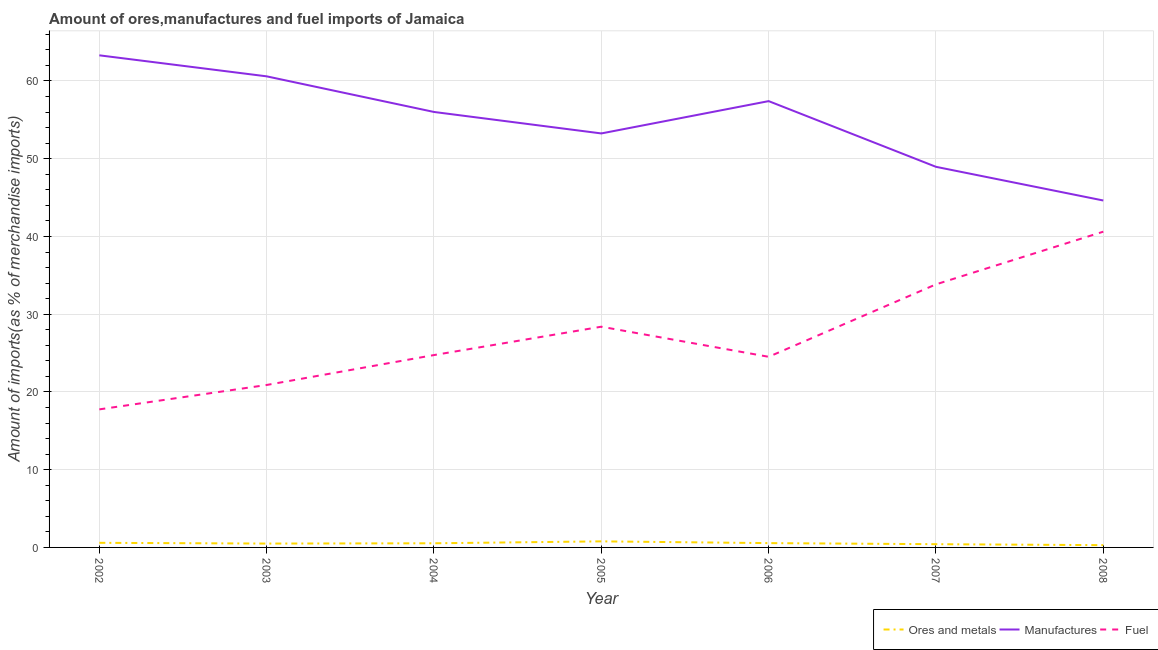Is the number of lines equal to the number of legend labels?
Your answer should be very brief. Yes. What is the percentage of fuel imports in 2008?
Keep it short and to the point. 40.62. Across all years, what is the maximum percentage of manufactures imports?
Keep it short and to the point. 63.3. Across all years, what is the minimum percentage of ores and metals imports?
Your response must be concise. 0.29. In which year was the percentage of manufactures imports minimum?
Keep it short and to the point. 2008. What is the total percentage of ores and metals imports in the graph?
Offer a very short reply. 3.67. What is the difference between the percentage of manufactures imports in 2004 and that in 2005?
Make the answer very short. 2.76. What is the difference between the percentage of ores and metals imports in 2004 and the percentage of fuel imports in 2005?
Offer a terse response. -27.86. What is the average percentage of manufactures imports per year?
Your answer should be very brief. 54.88. In the year 2007, what is the difference between the percentage of manufactures imports and percentage of ores and metals imports?
Your answer should be compact. 48.54. What is the ratio of the percentage of ores and metals imports in 2007 to that in 2008?
Your response must be concise. 1.43. Is the percentage of manufactures imports in 2007 less than that in 2008?
Ensure brevity in your answer.  No. What is the difference between the highest and the second highest percentage of manufactures imports?
Make the answer very short. 2.7. What is the difference between the highest and the lowest percentage of manufactures imports?
Your answer should be very brief. 18.68. Is the percentage of manufactures imports strictly greater than the percentage of fuel imports over the years?
Your answer should be compact. Yes. Is the percentage of manufactures imports strictly less than the percentage of fuel imports over the years?
Offer a very short reply. No. How many years are there in the graph?
Ensure brevity in your answer.  7. What is the difference between two consecutive major ticks on the Y-axis?
Give a very brief answer. 10. Does the graph contain grids?
Offer a terse response. Yes. What is the title of the graph?
Your response must be concise. Amount of ores,manufactures and fuel imports of Jamaica. What is the label or title of the Y-axis?
Offer a terse response. Amount of imports(as % of merchandise imports). What is the Amount of imports(as % of merchandise imports) of Ores and metals in 2002?
Provide a succinct answer. 0.59. What is the Amount of imports(as % of merchandise imports) in Manufactures in 2002?
Offer a very short reply. 63.3. What is the Amount of imports(as % of merchandise imports) in Fuel in 2002?
Keep it short and to the point. 17.76. What is the Amount of imports(as % of merchandise imports) in Ores and metals in 2003?
Provide a succinct answer. 0.5. What is the Amount of imports(as % of merchandise imports) in Manufactures in 2003?
Make the answer very short. 60.6. What is the Amount of imports(as % of merchandise imports) in Fuel in 2003?
Your answer should be very brief. 20.9. What is the Amount of imports(as % of merchandise imports) of Ores and metals in 2004?
Make the answer very short. 0.53. What is the Amount of imports(as % of merchandise imports) in Manufactures in 2004?
Make the answer very short. 56.01. What is the Amount of imports(as % of merchandise imports) of Fuel in 2004?
Offer a very short reply. 24.74. What is the Amount of imports(as % of merchandise imports) of Ores and metals in 2005?
Give a very brief answer. 0.78. What is the Amount of imports(as % of merchandise imports) of Manufactures in 2005?
Your answer should be very brief. 53.25. What is the Amount of imports(as % of merchandise imports) of Fuel in 2005?
Offer a terse response. 28.39. What is the Amount of imports(as % of merchandise imports) of Ores and metals in 2006?
Provide a short and direct response. 0.55. What is the Amount of imports(as % of merchandise imports) in Manufactures in 2006?
Provide a succinct answer. 57.41. What is the Amount of imports(as % of merchandise imports) in Fuel in 2006?
Keep it short and to the point. 24.52. What is the Amount of imports(as % of merchandise imports) of Ores and metals in 2007?
Your response must be concise. 0.42. What is the Amount of imports(as % of merchandise imports) in Manufactures in 2007?
Provide a succinct answer. 48.96. What is the Amount of imports(as % of merchandise imports) in Fuel in 2007?
Provide a short and direct response. 33.84. What is the Amount of imports(as % of merchandise imports) of Ores and metals in 2008?
Your response must be concise. 0.29. What is the Amount of imports(as % of merchandise imports) in Manufactures in 2008?
Keep it short and to the point. 44.63. What is the Amount of imports(as % of merchandise imports) in Fuel in 2008?
Provide a succinct answer. 40.62. Across all years, what is the maximum Amount of imports(as % of merchandise imports) of Ores and metals?
Keep it short and to the point. 0.78. Across all years, what is the maximum Amount of imports(as % of merchandise imports) of Manufactures?
Provide a succinct answer. 63.3. Across all years, what is the maximum Amount of imports(as % of merchandise imports) in Fuel?
Your response must be concise. 40.62. Across all years, what is the minimum Amount of imports(as % of merchandise imports) of Ores and metals?
Give a very brief answer. 0.29. Across all years, what is the minimum Amount of imports(as % of merchandise imports) of Manufactures?
Provide a succinct answer. 44.63. Across all years, what is the minimum Amount of imports(as % of merchandise imports) of Fuel?
Give a very brief answer. 17.76. What is the total Amount of imports(as % of merchandise imports) in Ores and metals in the graph?
Make the answer very short. 3.67. What is the total Amount of imports(as % of merchandise imports) of Manufactures in the graph?
Keep it short and to the point. 384.16. What is the total Amount of imports(as % of merchandise imports) in Fuel in the graph?
Keep it short and to the point. 190.77. What is the difference between the Amount of imports(as % of merchandise imports) of Ores and metals in 2002 and that in 2003?
Your answer should be very brief. 0.1. What is the difference between the Amount of imports(as % of merchandise imports) in Manufactures in 2002 and that in 2003?
Give a very brief answer. 2.7. What is the difference between the Amount of imports(as % of merchandise imports) of Fuel in 2002 and that in 2003?
Keep it short and to the point. -3.14. What is the difference between the Amount of imports(as % of merchandise imports) of Ores and metals in 2002 and that in 2004?
Make the answer very short. 0.06. What is the difference between the Amount of imports(as % of merchandise imports) of Manufactures in 2002 and that in 2004?
Ensure brevity in your answer.  7.29. What is the difference between the Amount of imports(as % of merchandise imports) of Fuel in 2002 and that in 2004?
Give a very brief answer. -6.99. What is the difference between the Amount of imports(as % of merchandise imports) in Ores and metals in 2002 and that in 2005?
Provide a short and direct response. -0.19. What is the difference between the Amount of imports(as % of merchandise imports) of Manufactures in 2002 and that in 2005?
Your answer should be compact. 10.05. What is the difference between the Amount of imports(as % of merchandise imports) of Fuel in 2002 and that in 2005?
Provide a succinct answer. -10.63. What is the difference between the Amount of imports(as % of merchandise imports) of Ores and metals in 2002 and that in 2006?
Your answer should be very brief. 0.04. What is the difference between the Amount of imports(as % of merchandise imports) of Manufactures in 2002 and that in 2006?
Keep it short and to the point. 5.89. What is the difference between the Amount of imports(as % of merchandise imports) of Fuel in 2002 and that in 2006?
Your answer should be very brief. -6.76. What is the difference between the Amount of imports(as % of merchandise imports) of Ores and metals in 2002 and that in 2007?
Provide a succinct answer. 0.18. What is the difference between the Amount of imports(as % of merchandise imports) in Manufactures in 2002 and that in 2007?
Your answer should be very brief. 14.34. What is the difference between the Amount of imports(as % of merchandise imports) of Fuel in 2002 and that in 2007?
Provide a short and direct response. -16.08. What is the difference between the Amount of imports(as % of merchandise imports) of Ores and metals in 2002 and that in 2008?
Offer a very short reply. 0.3. What is the difference between the Amount of imports(as % of merchandise imports) in Manufactures in 2002 and that in 2008?
Ensure brevity in your answer.  18.68. What is the difference between the Amount of imports(as % of merchandise imports) in Fuel in 2002 and that in 2008?
Your answer should be very brief. -22.86. What is the difference between the Amount of imports(as % of merchandise imports) of Ores and metals in 2003 and that in 2004?
Your response must be concise. -0.04. What is the difference between the Amount of imports(as % of merchandise imports) in Manufactures in 2003 and that in 2004?
Ensure brevity in your answer.  4.58. What is the difference between the Amount of imports(as % of merchandise imports) of Fuel in 2003 and that in 2004?
Your answer should be very brief. -3.85. What is the difference between the Amount of imports(as % of merchandise imports) in Ores and metals in 2003 and that in 2005?
Make the answer very short. -0.28. What is the difference between the Amount of imports(as % of merchandise imports) in Manufactures in 2003 and that in 2005?
Provide a short and direct response. 7.34. What is the difference between the Amount of imports(as % of merchandise imports) of Fuel in 2003 and that in 2005?
Offer a terse response. -7.5. What is the difference between the Amount of imports(as % of merchandise imports) of Ores and metals in 2003 and that in 2006?
Offer a terse response. -0.06. What is the difference between the Amount of imports(as % of merchandise imports) of Manufactures in 2003 and that in 2006?
Make the answer very short. 3.19. What is the difference between the Amount of imports(as % of merchandise imports) of Fuel in 2003 and that in 2006?
Your response must be concise. -3.62. What is the difference between the Amount of imports(as % of merchandise imports) of Ores and metals in 2003 and that in 2007?
Provide a succinct answer. 0.08. What is the difference between the Amount of imports(as % of merchandise imports) of Manufactures in 2003 and that in 2007?
Your answer should be very brief. 11.64. What is the difference between the Amount of imports(as % of merchandise imports) in Fuel in 2003 and that in 2007?
Provide a succinct answer. -12.94. What is the difference between the Amount of imports(as % of merchandise imports) in Ores and metals in 2003 and that in 2008?
Your answer should be compact. 0.2. What is the difference between the Amount of imports(as % of merchandise imports) of Manufactures in 2003 and that in 2008?
Offer a terse response. 15.97. What is the difference between the Amount of imports(as % of merchandise imports) of Fuel in 2003 and that in 2008?
Give a very brief answer. -19.72. What is the difference between the Amount of imports(as % of merchandise imports) of Ores and metals in 2004 and that in 2005?
Keep it short and to the point. -0.25. What is the difference between the Amount of imports(as % of merchandise imports) in Manufactures in 2004 and that in 2005?
Provide a short and direct response. 2.76. What is the difference between the Amount of imports(as % of merchandise imports) in Fuel in 2004 and that in 2005?
Provide a short and direct response. -3.65. What is the difference between the Amount of imports(as % of merchandise imports) in Ores and metals in 2004 and that in 2006?
Your answer should be compact. -0.02. What is the difference between the Amount of imports(as % of merchandise imports) of Manufactures in 2004 and that in 2006?
Your answer should be very brief. -1.4. What is the difference between the Amount of imports(as % of merchandise imports) of Fuel in 2004 and that in 2006?
Make the answer very short. 0.22. What is the difference between the Amount of imports(as % of merchandise imports) in Ores and metals in 2004 and that in 2007?
Keep it short and to the point. 0.12. What is the difference between the Amount of imports(as % of merchandise imports) of Manufactures in 2004 and that in 2007?
Provide a succinct answer. 7.06. What is the difference between the Amount of imports(as % of merchandise imports) of Fuel in 2004 and that in 2007?
Your response must be concise. -9.1. What is the difference between the Amount of imports(as % of merchandise imports) of Ores and metals in 2004 and that in 2008?
Your answer should be very brief. 0.24. What is the difference between the Amount of imports(as % of merchandise imports) of Manufactures in 2004 and that in 2008?
Your response must be concise. 11.39. What is the difference between the Amount of imports(as % of merchandise imports) in Fuel in 2004 and that in 2008?
Keep it short and to the point. -15.87. What is the difference between the Amount of imports(as % of merchandise imports) in Ores and metals in 2005 and that in 2006?
Make the answer very short. 0.23. What is the difference between the Amount of imports(as % of merchandise imports) in Manufactures in 2005 and that in 2006?
Provide a short and direct response. -4.16. What is the difference between the Amount of imports(as % of merchandise imports) in Fuel in 2005 and that in 2006?
Your answer should be very brief. 3.87. What is the difference between the Amount of imports(as % of merchandise imports) of Ores and metals in 2005 and that in 2007?
Your response must be concise. 0.36. What is the difference between the Amount of imports(as % of merchandise imports) of Manufactures in 2005 and that in 2007?
Your answer should be compact. 4.29. What is the difference between the Amount of imports(as % of merchandise imports) of Fuel in 2005 and that in 2007?
Ensure brevity in your answer.  -5.45. What is the difference between the Amount of imports(as % of merchandise imports) in Ores and metals in 2005 and that in 2008?
Your response must be concise. 0.49. What is the difference between the Amount of imports(as % of merchandise imports) in Manufactures in 2005 and that in 2008?
Provide a short and direct response. 8.63. What is the difference between the Amount of imports(as % of merchandise imports) of Fuel in 2005 and that in 2008?
Make the answer very short. -12.22. What is the difference between the Amount of imports(as % of merchandise imports) of Ores and metals in 2006 and that in 2007?
Give a very brief answer. 0.14. What is the difference between the Amount of imports(as % of merchandise imports) in Manufactures in 2006 and that in 2007?
Keep it short and to the point. 8.45. What is the difference between the Amount of imports(as % of merchandise imports) in Fuel in 2006 and that in 2007?
Offer a terse response. -9.32. What is the difference between the Amount of imports(as % of merchandise imports) in Ores and metals in 2006 and that in 2008?
Offer a very short reply. 0.26. What is the difference between the Amount of imports(as % of merchandise imports) in Manufactures in 2006 and that in 2008?
Give a very brief answer. 12.78. What is the difference between the Amount of imports(as % of merchandise imports) of Fuel in 2006 and that in 2008?
Provide a succinct answer. -16.1. What is the difference between the Amount of imports(as % of merchandise imports) of Ores and metals in 2007 and that in 2008?
Your answer should be compact. 0.12. What is the difference between the Amount of imports(as % of merchandise imports) of Manufactures in 2007 and that in 2008?
Offer a very short reply. 4.33. What is the difference between the Amount of imports(as % of merchandise imports) of Fuel in 2007 and that in 2008?
Keep it short and to the point. -6.78. What is the difference between the Amount of imports(as % of merchandise imports) of Ores and metals in 2002 and the Amount of imports(as % of merchandise imports) of Manufactures in 2003?
Give a very brief answer. -60. What is the difference between the Amount of imports(as % of merchandise imports) in Ores and metals in 2002 and the Amount of imports(as % of merchandise imports) in Fuel in 2003?
Make the answer very short. -20.3. What is the difference between the Amount of imports(as % of merchandise imports) of Manufactures in 2002 and the Amount of imports(as % of merchandise imports) of Fuel in 2003?
Your response must be concise. 42.41. What is the difference between the Amount of imports(as % of merchandise imports) in Ores and metals in 2002 and the Amount of imports(as % of merchandise imports) in Manufactures in 2004?
Keep it short and to the point. -55.42. What is the difference between the Amount of imports(as % of merchandise imports) in Ores and metals in 2002 and the Amount of imports(as % of merchandise imports) in Fuel in 2004?
Ensure brevity in your answer.  -24.15. What is the difference between the Amount of imports(as % of merchandise imports) in Manufactures in 2002 and the Amount of imports(as % of merchandise imports) in Fuel in 2004?
Keep it short and to the point. 38.56. What is the difference between the Amount of imports(as % of merchandise imports) in Ores and metals in 2002 and the Amount of imports(as % of merchandise imports) in Manufactures in 2005?
Your answer should be compact. -52.66. What is the difference between the Amount of imports(as % of merchandise imports) in Ores and metals in 2002 and the Amount of imports(as % of merchandise imports) in Fuel in 2005?
Offer a very short reply. -27.8. What is the difference between the Amount of imports(as % of merchandise imports) of Manufactures in 2002 and the Amount of imports(as % of merchandise imports) of Fuel in 2005?
Your answer should be compact. 34.91. What is the difference between the Amount of imports(as % of merchandise imports) of Ores and metals in 2002 and the Amount of imports(as % of merchandise imports) of Manufactures in 2006?
Keep it short and to the point. -56.82. What is the difference between the Amount of imports(as % of merchandise imports) in Ores and metals in 2002 and the Amount of imports(as % of merchandise imports) in Fuel in 2006?
Make the answer very short. -23.93. What is the difference between the Amount of imports(as % of merchandise imports) in Manufactures in 2002 and the Amount of imports(as % of merchandise imports) in Fuel in 2006?
Your answer should be compact. 38.78. What is the difference between the Amount of imports(as % of merchandise imports) of Ores and metals in 2002 and the Amount of imports(as % of merchandise imports) of Manufactures in 2007?
Offer a very short reply. -48.36. What is the difference between the Amount of imports(as % of merchandise imports) of Ores and metals in 2002 and the Amount of imports(as % of merchandise imports) of Fuel in 2007?
Offer a terse response. -33.25. What is the difference between the Amount of imports(as % of merchandise imports) of Manufactures in 2002 and the Amount of imports(as % of merchandise imports) of Fuel in 2007?
Provide a succinct answer. 29.46. What is the difference between the Amount of imports(as % of merchandise imports) of Ores and metals in 2002 and the Amount of imports(as % of merchandise imports) of Manufactures in 2008?
Your response must be concise. -44.03. What is the difference between the Amount of imports(as % of merchandise imports) of Ores and metals in 2002 and the Amount of imports(as % of merchandise imports) of Fuel in 2008?
Provide a short and direct response. -40.02. What is the difference between the Amount of imports(as % of merchandise imports) of Manufactures in 2002 and the Amount of imports(as % of merchandise imports) of Fuel in 2008?
Make the answer very short. 22.68. What is the difference between the Amount of imports(as % of merchandise imports) in Ores and metals in 2003 and the Amount of imports(as % of merchandise imports) in Manufactures in 2004?
Make the answer very short. -55.52. What is the difference between the Amount of imports(as % of merchandise imports) in Ores and metals in 2003 and the Amount of imports(as % of merchandise imports) in Fuel in 2004?
Make the answer very short. -24.25. What is the difference between the Amount of imports(as % of merchandise imports) in Manufactures in 2003 and the Amount of imports(as % of merchandise imports) in Fuel in 2004?
Your response must be concise. 35.85. What is the difference between the Amount of imports(as % of merchandise imports) of Ores and metals in 2003 and the Amount of imports(as % of merchandise imports) of Manufactures in 2005?
Ensure brevity in your answer.  -52.76. What is the difference between the Amount of imports(as % of merchandise imports) in Ores and metals in 2003 and the Amount of imports(as % of merchandise imports) in Fuel in 2005?
Offer a terse response. -27.9. What is the difference between the Amount of imports(as % of merchandise imports) in Manufactures in 2003 and the Amount of imports(as % of merchandise imports) in Fuel in 2005?
Your response must be concise. 32.2. What is the difference between the Amount of imports(as % of merchandise imports) of Ores and metals in 2003 and the Amount of imports(as % of merchandise imports) of Manufactures in 2006?
Your answer should be compact. -56.91. What is the difference between the Amount of imports(as % of merchandise imports) in Ores and metals in 2003 and the Amount of imports(as % of merchandise imports) in Fuel in 2006?
Make the answer very short. -24.02. What is the difference between the Amount of imports(as % of merchandise imports) of Manufactures in 2003 and the Amount of imports(as % of merchandise imports) of Fuel in 2006?
Your answer should be compact. 36.08. What is the difference between the Amount of imports(as % of merchandise imports) in Ores and metals in 2003 and the Amount of imports(as % of merchandise imports) in Manufactures in 2007?
Your answer should be very brief. -48.46. What is the difference between the Amount of imports(as % of merchandise imports) in Ores and metals in 2003 and the Amount of imports(as % of merchandise imports) in Fuel in 2007?
Provide a succinct answer. -33.34. What is the difference between the Amount of imports(as % of merchandise imports) of Manufactures in 2003 and the Amount of imports(as % of merchandise imports) of Fuel in 2007?
Provide a succinct answer. 26.76. What is the difference between the Amount of imports(as % of merchandise imports) in Ores and metals in 2003 and the Amount of imports(as % of merchandise imports) in Manufactures in 2008?
Make the answer very short. -44.13. What is the difference between the Amount of imports(as % of merchandise imports) of Ores and metals in 2003 and the Amount of imports(as % of merchandise imports) of Fuel in 2008?
Provide a short and direct response. -40.12. What is the difference between the Amount of imports(as % of merchandise imports) in Manufactures in 2003 and the Amount of imports(as % of merchandise imports) in Fuel in 2008?
Your answer should be compact. 19.98. What is the difference between the Amount of imports(as % of merchandise imports) of Ores and metals in 2004 and the Amount of imports(as % of merchandise imports) of Manufactures in 2005?
Your answer should be compact. -52.72. What is the difference between the Amount of imports(as % of merchandise imports) of Ores and metals in 2004 and the Amount of imports(as % of merchandise imports) of Fuel in 2005?
Provide a succinct answer. -27.86. What is the difference between the Amount of imports(as % of merchandise imports) in Manufactures in 2004 and the Amount of imports(as % of merchandise imports) in Fuel in 2005?
Offer a very short reply. 27.62. What is the difference between the Amount of imports(as % of merchandise imports) of Ores and metals in 2004 and the Amount of imports(as % of merchandise imports) of Manufactures in 2006?
Your answer should be very brief. -56.88. What is the difference between the Amount of imports(as % of merchandise imports) of Ores and metals in 2004 and the Amount of imports(as % of merchandise imports) of Fuel in 2006?
Ensure brevity in your answer.  -23.99. What is the difference between the Amount of imports(as % of merchandise imports) in Manufactures in 2004 and the Amount of imports(as % of merchandise imports) in Fuel in 2006?
Provide a short and direct response. 31.49. What is the difference between the Amount of imports(as % of merchandise imports) in Ores and metals in 2004 and the Amount of imports(as % of merchandise imports) in Manufactures in 2007?
Keep it short and to the point. -48.42. What is the difference between the Amount of imports(as % of merchandise imports) of Ores and metals in 2004 and the Amount of imports(as % of merchandise imports) of Fuel in 2007?
Offer a terse response. -33.31. What is the difference between the Amount of imports(as % of merchandise imports) of Manufactures in 2004 and the Amount of imports(as % of merchandise imports) of Fuel in 2007?
Give a very brief answer. 22.17. What is the difference between the Amount of imports(as % of merchandise imports) in Ores and metals in 2004 and the Amount of imports(as % of merchandise imports) in Manufactures in 2008?
Give a very brief answer. -44.09. What is the difference between the Amount of imports(as % of merchandise imports) in Ores and metals in 2004 and the Amount of imports(as % of merchandise imports) in Fuel in 2008?
Offer a very short reply. -40.08. What is the difference between the Amount of imports(as % of merchandise imports) of Manufactures in 2004 and the Amount of imports(as % of merchandise imports) of Fuel in 2008?
Keep it short and to the point. 15.4. What is the difference between the Amount of imports(as % of merchandise imports) of Ores and metals in 2005 and the Amount of imports(as % of merchandise imports) of Manufactures in 2006?
Provide a short and direct response. -56.63. What is the difference between the Amount of imports(as % of merchandise imports) in Ores and metals in 2005 and the Amount of imports(as % of merchandise imports) in Fuel in 2006?
Keep it short and to the point. -23.74. What is the difference between the Amount of imports(as % of merchandise imports) of Manufactures in 2005 and the Amount of imports(as % of merchandise imports) of Fuel in 2006?
Offer a very short reply. 28.73. What is the difference between the Amount of imports(as % of merchandise imports) of Ores and metals in 2005 and the Amount of imports(as % of merchandise imports) of Manufactures in 2007?
Provide a succinct answer. -48.18. What is the difference between the Amount of imports(as % of merchandise imports) in Ores and metals in 2005 and the Amount of imports(as % of merchandise imports) in Fuel in 2007?
Keep it short and to the point. -33.06. What is the difference between the Amount of imports(as % of merchandise imports) in Manufactures in 2005 and the Amount of imports(as % of merchandise imports) in Fuel in 2007?
Your answer should be very brief. 19.41. What is the difference between the Amount of imports(as % of merchandise imports) of Ores and metals in 2005 and the Amount of imports(as % of merchandise imports) of Manufactures in 2008?
Provide a succinct answer. -43.85. What is the difference between the Amount of imports(as % of merchandise imports) of Ores and metals in 2005 and the Amount of imports(as % of merchandise imports) of Fuel in 2008?
Your answer should be compact. -39.84. What is the difference between the Amount of imports(as % of merchandise imports) in Manufactures in 2005 and the Amount of imports(as % of merchandise imports) in Fuel in 2008?
Give a very brief answer. 12.64. What is the difference between the Amount of imports(as % of merchandise imports) of Ores and metals in 2006 and the Amount of imports(as % of merchandise imports) of Manufactures in 2007?
Give a very brief answer. -48.4. What is the difference between the Amount of imports(as % of merchandise imports) in Ores and metals in 2006 and the Amount of imports(as % of merchandise imports) in Fuel in 2007?
Your answer should be very brief. -33.28. What is the difference between the Amount of imports(as % of merchandise imports) of Manufactures in 2006 and the Amount of imports(as % of merchandise imports) of Fuel in 2007?
Offer a very short reply. 23.57. What is the difference between the Amount of imports(as % of merchandise imports) in Ores and metals in 2006 and the Amount of imports(as % of merchandise imports) in Manufactures in 2008?
Your answer should be very brief. -44.07. What is the difference between the Amount of imports(as % of merchandise imports) in Ores and metals in 2006 and the Amount of imports(as % of merchandise imports) in Fuel in 2008?
Provide a short and direct response. -40.06. What is the difference between the Amount of imports(as % of merchandise imports) of Manufactures in 2006 and the Amount of imports(as % of merchandise imports) of Fuel in 2008?
Offer a very short reply. 16.79. What is the difference between the Amount of imports(as % of merchandise imports) of Ores and metals in 2007 and the Amount of imports(as % of merchandise imports) of Manufactures in 2008?
Give a very brief answer. -44.21. What is the difference between the Amount of imports(as % of merchandise imports) in Ores and metals in 2007 and the Amount of imports(as % of merchandise imports) in Fuel in 2008?
Offer a terse response. -40.2. What is the difference between the Amount of imports(as % of merchandise imports) of Manufactures in 2007 and the Amount of imports(as % of merchandise imports) of Fuel in 2008?
Offer a very short reply. 8.34. What is the average Amount of imports(as % of merchandise imports) of Ores and metals per year?
Offer a terse response. 0.52. What is the average Amount of imports(as % of merchandise imports) in Manufactures per year?
Offer a very short reply. 54.88. What is the average Amount of imports(as % of merchandise imports) of Fuel per year?
Give a very brief answer. 27.25. In the year 2002, what is the difference between the Amount of imports(as % of merchandise imports) of Ores and metals and Amount of imports(as % of merchandise imports) of Manufactures?
Provide a succinct answer. -62.71. In the year 2002, what is the difference between the Amount of imports(as % of merchandise imports) in Ores and metals and Amount of imports(as % of merchandise imports) in Fuel?
Offer a very short reply. -17.17. In the year 2002, what is the difference between the Amount of imports(as % of merchandise imports) of Manufactures and Amount of imports(as % of merchandise imports) of Fuel?
Your answer should be compact. 45.54. In the year 2003, what is the difference between the Amount of imports(as % of merchandise imports) of Ores and metals and Amount of imports(as % of merchandise imports) of Manufactures?
Keep it short and to the point. -60.1. In the year 2003, what is the difference between the Amount of imports(as % of merchandise imports) in Ores and metals and Amount of imports(as % of merchandise imports) in Fuel?
Your answer should be compact. -20.4. In the year 2003, what is the difference between the Amount of imports(as % of merchandise imports) in Manufactures and Amount of imports(as % of merchandise imports) in Fuel?
Offer a very short reply. 39.7. In the year 2004, what is the difference between the Amount of imports(as % of merchandise imports) of Ores and metals and Amount of imports(as % of merchandise imports) of Manufactures?
Make the answer very short. -55.48. In the year 2004, what is the difference between the Amount of imports(as % of merchandise imports) of Ores and metals and Amount of imports(as % of merchandise imports) of Fuel?
Offer a very short reply. -24.21. In the year 2004, what is the difference between the Amount of imports(as % of merchandise imports) in Manufactures and Amount of imports(as % of merchandise imports) in Fuel?
Make the answer very short. 31.27. In the year 2005, what is the difference between the Amount of imports(as % of merchandise imports) of Ores and metals and Amount of imports(as % of merchandise imports) of Manufactures?
Ensure brevity in your answer.  -52.47. In the year 2005, what is the difference between the Amount of imports(as % of merchandise imports) of Ores and metals and Amount of imports(as % of merchandise imports) of Fuel?
Make the answer very short. -27.61. In the year 2005, what is the difference between the Amount of imports(as % of merchandise imports) of Manufactures and Amount of imports(as % of merchandise imports) of Fuel?
Keep it short and to the point. 24.86. In the year 2006, what is the difference between the Amount of imports(as % of merchandise imports) in Ores and metals and Amount of imports(as % of merchandise imports) in Manufactures?
Ensure brevity in your answer.  -56.85. In the year 2006, what is the difference between the Amount of imports(as % of merchandise imports) in Ores and metals and Amount of imports(as % of merchandise imports) in Fuel?
Make the answer very short. -23.97. In the year 2006, what is the difference between the Amount of imports(as % of merchandise imports) in Manufactures and Amount of imports(as % of merchandise imports) in Fuel?
Keep it short and to the point. 32.89. In the year 2007, what is the difference between the Amount of imports(as % of merchandise imports) of Ores and metals and Amount of imports(as % of merchandise imports) of Manufactures?
Provide a succinct answer. -48.54. In the year 2007, what is the difference between the Amount of imports(as % of merchandise imports) in Ores and metals and Amount of imports(as % of merchandise imports) in Fuel?
Ensure brevity in your answer.  -33.42. In the year 2007, what is the difference between the Amount of imports(as % of merchandise imports) of Manufactures and Amount of imports(as % of merchandise imports) of Fuel?
Your answer should be compact. 15.12. In the year 2008, what is the difference between the Amount of imports(as % of merchandise imports) in Ores and metals and Amount of imports(as % of merchandise imports) in Manufactures?
Keep it short and to the point. -44.33. In the year 2008, what is the difference between the Amount of imports(as % of merchandise imports) of Ores and metals and Amount of imports(as % of merchandise imports) of Fuel?
Give a very brief answer. -40.32. In the year 2008, what is the difference between the Amount of imports(as % of merchandise imports) in Manufactures and Amount of imports(as % of merchandise imports) in Fuel?
Offer a terse response. 4.01. What is the ratio of the Amount of imports(as % of merchandise imports) in Ores and metals in 2002 to that in 2003?
Offer a very short reply. 1.19. What is the ratio of the Amount of imports(as % of merchandise imports) of Manufactures in 2002 to that in 2003?
Your response must be concise. 1.04. What is the ratio of the Amount of imports(as % of merchandise imports) of Fuel in 2002 to that in 2003?
Keep it short and to the point. 0.85. What is the ratio of the Amount of imports(as % of merchandise imports) in Ores and metals in 2002 to that in 2004?
Offer a very short reply. 1.11. What is the ratio of the Amount of imports(as % of merchandise imports) of Manufactures in 2002 to that in 2004?
Ensure brevity in your answer.  1.13. What is the ratio of the Amount of imports(as % of merchandise imports) of Fuel in 2002 to that in 2004?
Keep it short and to the point. 0.72. What is the ratio of the Amount of imports(as % of merchandise imports) of Ores and metals in 2002 to that in 2005?
Keep it short and to the point. 0.76. What is the ratio of the Amount of imports(as % of merchandise imports) in Manufactures in 2002 to that in 2005?
Provide a short and direct response. 1.19. What is the ratio of the Amount of imports(as % of merchandise imports) of Fuel in 2002 to that in 2005?
Offer a very short reply. 0.63. What is the ratio of the Amount of imports(as % of merchandise imports) of Ores and metals in 2002 to that in 2006?
Keep it short and to the point. 1.07. What is the ratio of the Amount of imports(as % of merchandise imports) of Manufactures in 2002 to that in 2006?
Your response must be concise. 1.1. What is the ratio of the Amount of imports(as % of merchandise imports) in Fuel in 2002 to that in 2006?
Your answer should be compact. 0.72. What is the ratio of the Amount of imports(as % of merchandise imports) in Ores and metals in 2002 to that in 2007?
Give a very brief answer. 1.42. What is the ratio of the Amount of imports(as % of merchandise imports) of Manufactures in 2002 to that in 2007?
Give a very brief answer. 1.29. What is the ratio of the Amount of imports(as % of merchandise imports) of Fuel in 2002 to that in 2007?
Give a very brief answer. 0.52. What is the ratio of the Amount of imports(as % of merchandise imports) in Ores and metals in 2002 to that in 2008?
Make the answer very short. 2.03. What is the ratio of the Amount of imports(as % of merchandise imports) in Manufactures in 2002 to that in 2008?
Give a very brief answer. 1.42. What is the ratio of the Amount of imports(as % of merchandise imports) of Fuel in 2002 to that in 2008?
Ensure brevity in your answer.  0.44. What is the ratio of the Amount of imports(as % of merchandise imports) of Ores and metals in 2003 to that in 2004?
Provide a short and direct response. 0.93. What is the ratio of the Amount of imports(as % of merchandise imports) in Manufactures in 2003 to that in 2004?
Provide a short and direct response. 1.08. What is the ratio of the Amount of imports(as % of merchandise imports) in Fuel in 2003 to that in 2004?
Your answer should be very brief. 0.84. What is the ratio of the Amount of imports(as % of merchandise imports) of Ores and metals in 2003 to that in 2005?
Make the answer very short. 0.64. What is the ratio of the Amount of imports(as % of merchandise imports) in Manufactures in 2003 to that in 2005?
Keep it short and to the point. 1.14. What is the ratio of the Amount of imports(as % of merchandise imports) of Fuel in 2003 to that in 2005?
Ensure brevity in your answer.  0.74. What is the ratio of the Amount of imports(as % of merchandise imports) of Ores and metals in 2003 to that in 2006?
Offer a terse response. 0.9. What is the ratio of the Amount of imports(as % of merchandise imports) in Manufactures in 2003 to that in 2006?
Make the answer very short. 1.06. What is the ratio of the Amount of imports(as % of merchandise imports) in Fuel in 2003 to that in 2006?
Your response must be concise. 0.85. What is the ratio of the Amount of imports(as % of merchandise imports) in Ores and metals in 2003 to that in 2007?
Keep it short and to the point. 1.19. What is the ratio of the Amount of imports(as % of merchandise imports) in Manufactures in 2003 to that in 2007?
Your answer should be very brief. 1.24. What is the ratio of the Amount of imports(as % of merchandise imports) of Fuel in 2003 to that in 2007?
Give a very brief answer. 0.62. What is the ratio of the Amount of imports(as % of merchandise imports) in Ores and metals in 2003 to that in 2008?
Your answer should be compact. 1.7. What is the ratio of the Amount of imports(as % of merchandise imports) in Manufactures in 2003 to that in 2008?
Keep it short and to the point. 1.36. What is the ratio of the Amount of imports(as % of merchandise imports) in Fuel in 2003 to that in 2008?
Make the answer very short. 0.51. What is the ratio of the Amount of imports(as % of merchandise imports) in Ores and metals in 2004 to that in 2005?
Provide a short and direct response. 0.68. What is the ratio of the Amount of imports(as % of merchandise imports) in Manufactures in 2004 to that in 2005?
Your answer should be very brief. 1.05. What is the ratio of the Amount of imports(as % of merchandise imports) of Fuel in 2004 to that in 2005?
Provide a short and direct response. 0.87. What is the ratio of the Amount of imports(as % of merchandise imports) in Ores and metals in 2004 to that in 2006?
Your answer should be compact. 0.96. What is the ratio of the Amount of imports(as % of merchandise imports) of Manufactures in 2004 to that in 2006?
Your response must be concise. 0.98. What is the ratio of the Amount of imports(as % of merchandise imports) of Fuel in 2004 to that in 2006?
Your response must be concise. 1.01. What is the ratio of the Amount of imports(as % of merchandise imports) of Ores and metals in 2004 to that in 2007?
Provide a succinct answer. 1.28. What is the ratio of the Amount of imports(as % of merchandise imports) of Manufactures in 2004 to that in 2007?
Ensure brevity in your answer.  1.14. What is the ratio of the Amount of imports(as % of merchandise imports) of Fuel in 2004 to that in 2007?
Offer a very short reply. 0.73. What is the ratio of the Amount of imports(as % of merchandise imports) in Ores and metals in 2004 to that in 2008?
Make the answer very short. 1.82. What is the ratio of the Amount of imports(as % of merchandise imports) in Manufactures in 2004 to that in 2008?
Offer a terse response. 1.26. What is the ratio of the Amount of imports(as % of merchandise imports) in Fuel in 2004 to that in 2008?
Provide a succinct answer. 0.61. What is the ratio of the Amount of imports(as % of merchandise imports) of Ores and metals in 2005 to that in 2006?
Provide a short and direct response. 1.41. What is the ratio of the Amount of imports(as % of merchandise imports) in Manufactures in 2005 to that in 2006?
Make the answer very short. 0.93. What is the ratio of the Amount of imports(as % of merchandise imports) of Fuel in 2005 to that in 2006?
Give a very brief answer. 1.16. What is the ratio of the Amount of imports(as % of merchandise imports) in Ores and metals in 2005 to that in 2007?
Offer a very short reply. 1.87. What is the ratio of the Amount of imports(as % of merchandise imports) of Manufactures in 2005 to that in 2007?
Your answer should be very brief. 1.09. What is the ratio of the Amount of imports(as % of merchandise imports) in Fuel in 2005 to that in 2007?
Your answer should be compact. 0.84. What is the ratio of the Amount of imports(as % of merchandise imports) in Ores and metals in 2005 to that in 2008?
Provide a succinct answer. 2.67. What is the ratio of the Amount of imports(as % of merchandise imports) of Manufactures in 2005 to that in 2008?
Ensure brevity in your answer.  1.19. What is the ratio of the Amount of imports(as % of merchandise imports) of Fuel in 2005 to that in 2008?
Provide a short and direct response. 0.7. What is the ratio of the Amount of imports(as % of merchandise imports) of Ores and metals in 2006 to that in 2007?
Your response must be concise. 1.33. What is the ratio of the Amount of imports(as % of merchandise imports) in Manufactures in 2006 to that in 2007?
Give a very brief answer. 1.17. What is the ratio of the Amount of imports(as % of merchandise imports) of Fuel in 2006 to that in 2007?
Provide a succinct answer. 0.72. What is the ratio of the Amount of imports(as % of merchandise imports) of Ores and metals in 2006 to that in 2008?
Your response must be concise. 1.9. What is the ratio of the Amount of imports(as % of merchandise imports) in Manufactures in 2006 to that in 2008?
Provide a short and direct response. 1.29. What is the ratio of the Amount of imports(as % of merchandise imports) in Fuel in 2006 to that in 2008?
Provide a succinct answer. 0.6. What is the ratio of the Amount of imports(as % of merchandise imports) of Ores and metals in 2007 to that in 2008?
Keep it short and to the point. 1.43. What is the ratio of the Amount of imports(as % of merchandise imports) in Manufactures in 2007 to that in 2008?
Offer a terse response. 1.1. What is the ratio of the Amount of imports(as % of merchandise imports) of Fuel in 2007 to that in 2008?
Make the answer very short. 0.83. What is the difference between the highest and the second highest Amount of imports(as % of merchandise imports) of Ores and metals?
Ensure brevity in your answer.  0.19. What is the difference between the highest and the second highest Amount of imports(as % of merchandise imports) of Manufactures?
Give a very brief answer. 2.7. What is the difference between the highest and the second highest Amount of imports(as % of merchandise imports) in Fuel?
Offer a very short reply. 6.78. What is the difference between the highest and the lowest Amount of imports(as % of merchandise imports) in Ores and metals?
Provide a short and direct response. 0.49. What is the difference between the highest and the lowest Amount of imports(as % of merchandise imports) in Manufactures?
Ensure brevity in your answer.  18.68. What is the difference between the highest and the lowest Amount of imports(as % of merchandise imports) in Fuel?
Keep it short and to the point. 22.86. 